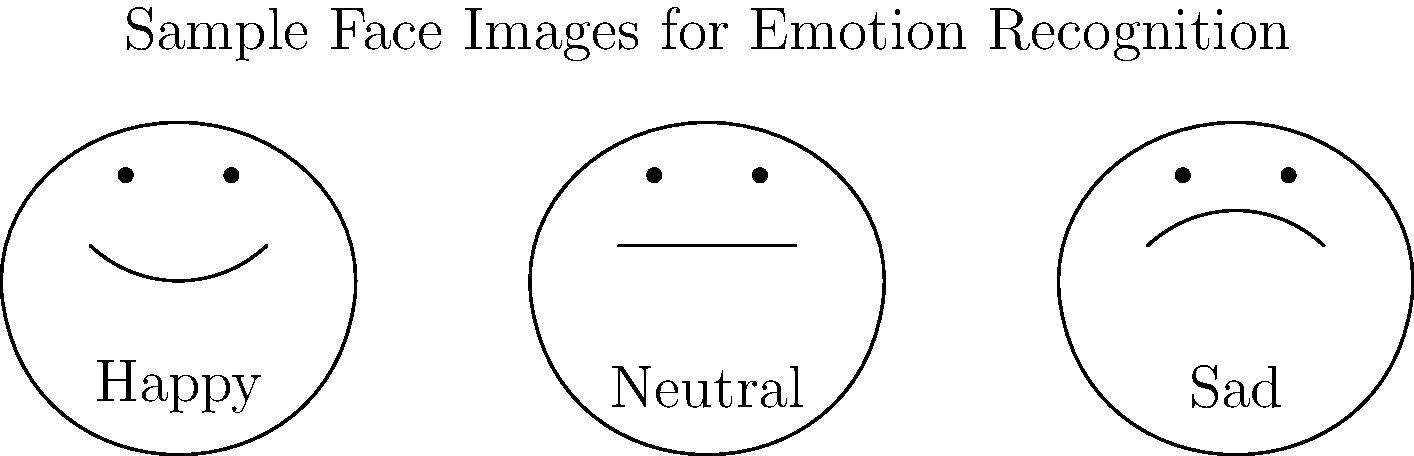In the context of deep learning for facial expression recognition, consider a convolutional neural network (CNN) architecture. How would you modify the final layer of the CNN to classify the emotions shown in the sample face images, and what loss function would be most appropriate for this task? To adapt a CNN for facial expression recognition:

1. Modify the final layer:
   - Replace the final fully connected layer with a new one.
   - Set the number of output neurons to match the number of emotion classes (in this case, 3: Happy, Neutral, Sad).
   - Use a softmax activation function for multi-class classification.

2. Loss function selection:
   - Use categorical cross-entropy loss, defined as:
     $$L = -\sum_{i=1}^{C} y_i \log(\hat{y}_i)$$
     where $C$ is the number of classes, $y_i$ is the true label, and $\hat{y}_i$ is the predicted probability.

3. Reasoning:
   - Softmax activation ensures the output probabilities sum to 1.
   - Categorical cross-entropy is suitable for multi-class problems and works well with softmax.

4. Training process:
   - Use backpropagation to update weights.
   - Minimize the categorical cross-entropy loss.

5. Mathematical perspective:
   - The softmax function is given by:
     $$\sigma(z)_j = \frac{e^{z_j}}{\sum_{k=1}^{K} e^{z_k}}$$
     for $j = 1, ..., K$, where $K$ is the number of classes.

6. Abstract algebra connection:
   - The softmax function can be viewed as a smooth approximation of the argmax function, relating to the concept of smooth manifolds in differential geometry.
Answer: Modify final layer to 3 neurons with softmax activation; use categorical cross-entropy loss. 